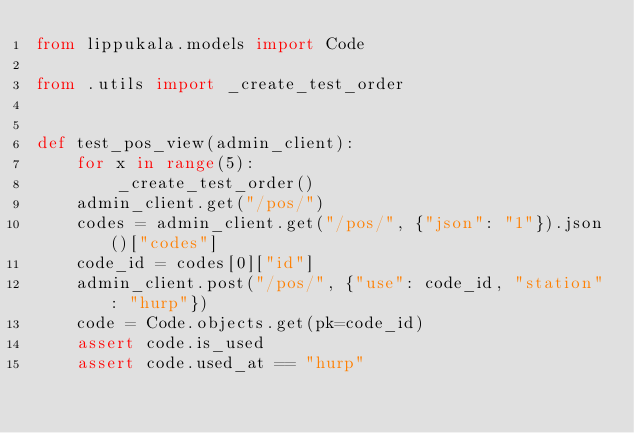Convert code to text. <code><loc_0><loc_0><loc_500><loc_500><_Python_>from lippukala.models import Code

from .utils import _create_test_order


def test_pos_view(admin_client):
    for x in range(5):
        _create_test_order()
    admin_client.get("/pos/")
    codes = admin_client.get("/pos/", {"json": "1"}).json()["codes"]
    code_id = codes[0]["id"]
    admin_client.post("/pos/", {"use": code_id, "station": "hurp"})
    code = Code.objects.get(pk=code_id)
    assert code.is_used
    assert code.used_at == "hurp"
</code> 